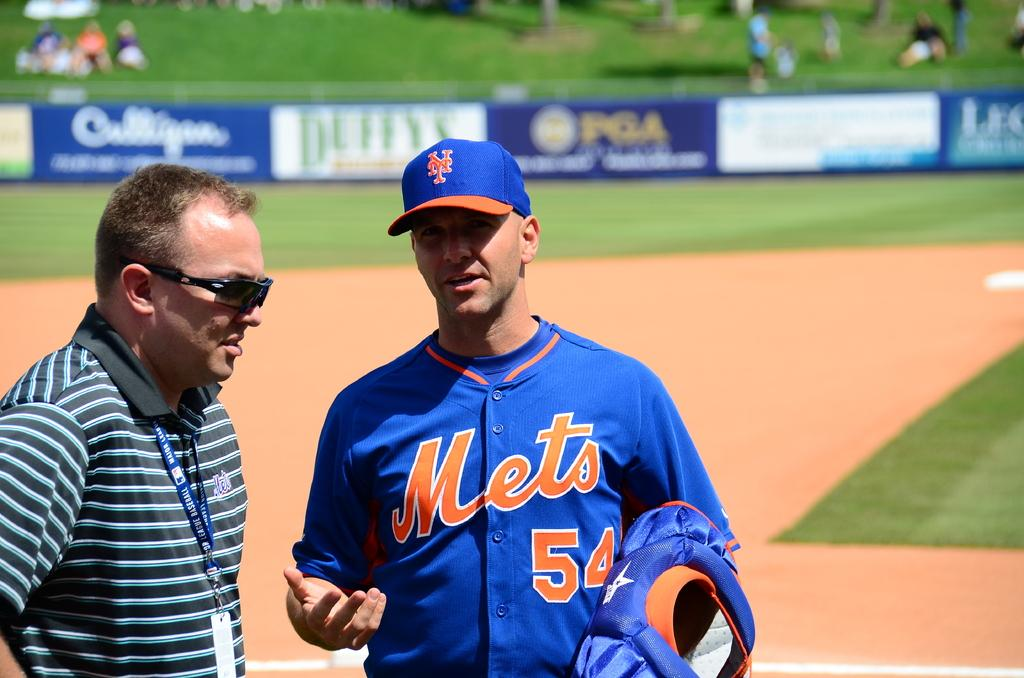<image>
Provide a brief description of the given image. Player number 54 for the Mets talks with a man in sunglasses. 